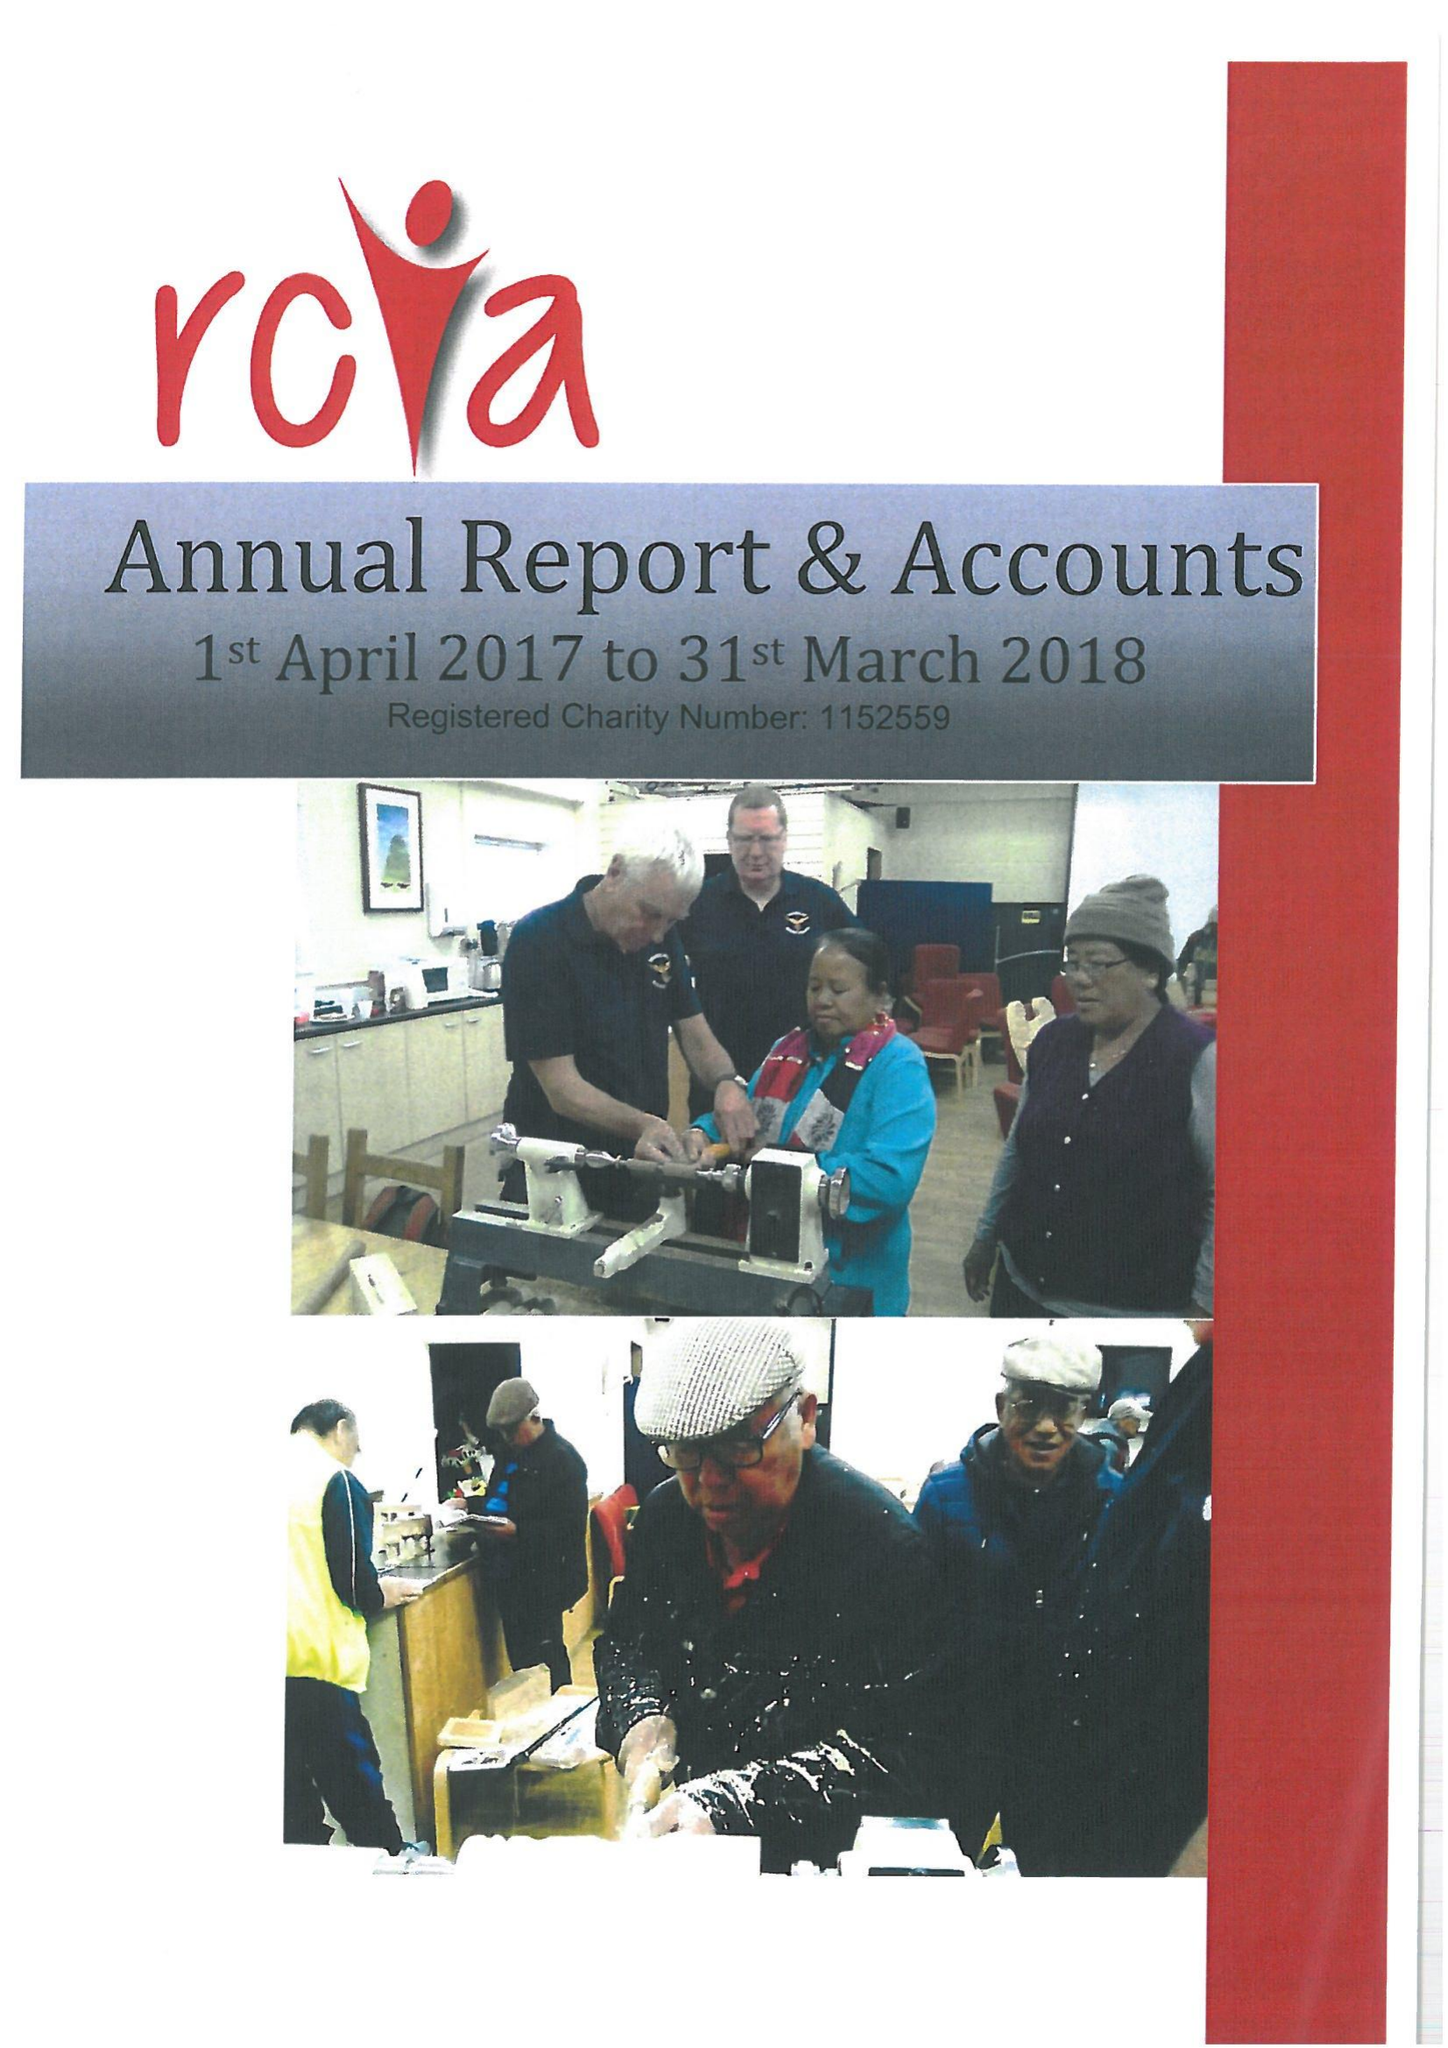What is the value for the spending_annually_in_british_pounds?
Answer the question using a single word or phrase. 56463.00 